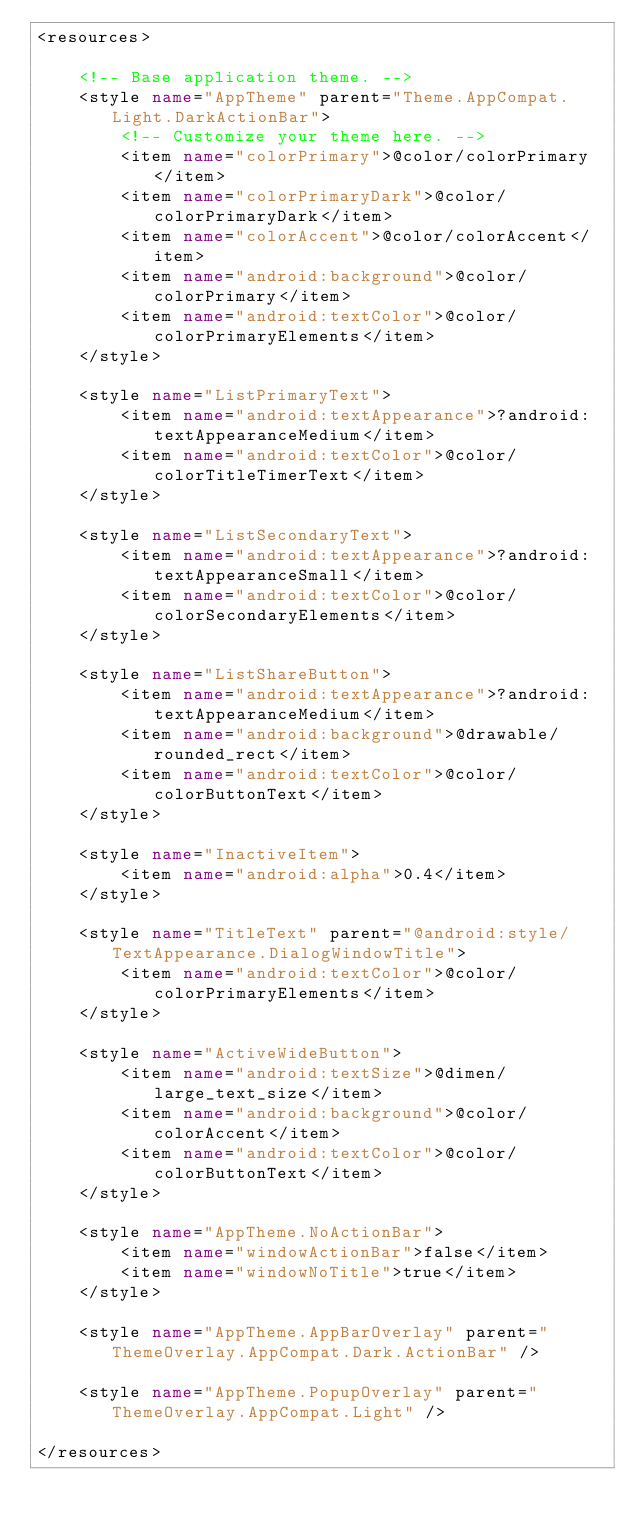<code> <loc_0><loc_0><loc_500><loc_500><_XML_><resources>

    <!-- Base application theme. -->
    <style name="AppTheme" parent="Theme.AppCompat.Light.DarkActionBar">
        <!-- Customize your theme here. -->
        <item name="colorPrimary">@color/colorPrimary</item>
        <item name="colorPrimaryDark">@color/colorPrimaryDark</item>
        <item name="colorAccent">@color/colorAccent</item>
        <item name="android:background">@color/colorPrimary</item>
        <item name="android:textColor">@color/colorPrimaryElements</item>
    </style>

    <style name="ListPrimaryText">
        <item name="android:textAppearance">?android:textAppearanceMedium</item>
        <item name="android:textColor">@color/colorTitleTimerText</item>
    </style>

    <style name="ListSecondaryText">
        <item name="android:textAppearance">?android:textAppearanceSmall</item>
        <item name="android:textColor">@color/colorSecondaryElements</item>
    </style>

    <style name="ListShareButton">
        <item name="android:textAppearance">?android:textAppearanceMedium</item>
        <item name="android:background">@drawable/rounded_rect</item>
        <item name="android:textColor">@color/colorButtonText</item>
    </style>

    <style name="InactiveItem">
        <item name="android:alpha">0.4</item>
    </style>

    <style name="TitleText" parent="@android:style/TextAppearance.DialogWindowTitle">
        <item name="android:textColor">@color/colorPrimaryElements</item>
    </style>

    <style name="ActiveWideButton">
        <item name="android:textSize">@dimen/large_text_size</item>
        <item name="android:background">@color/colorAccent</item>
        <item name="android:textColor">@color/colorButtonText</item>
    </style>

    <style name="AppTheme.NoActionBar">
        <item name="windowActionBar">false</item>
        <item name="windowNoTitle">true</item>
    </style>

    <style name="AppTheme.AppBarOverlay" parent="ThemeOverlay.AppCompat.Dark.ActionBar" />

    <style name="AppTheme.PopupOverlay" parent="ThemeOverlay.AppCompat.Light" />

</resources>
</code> 